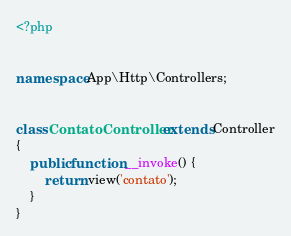Convert code to text. <code><loc_0><loc_0><loc_500><loc_500><_PHP_><?php


namespace App\Http\Controllers;


class ContatoController extends Controller
{
    public function __invoke() {
        return view('contato');
    }
}
</code> 